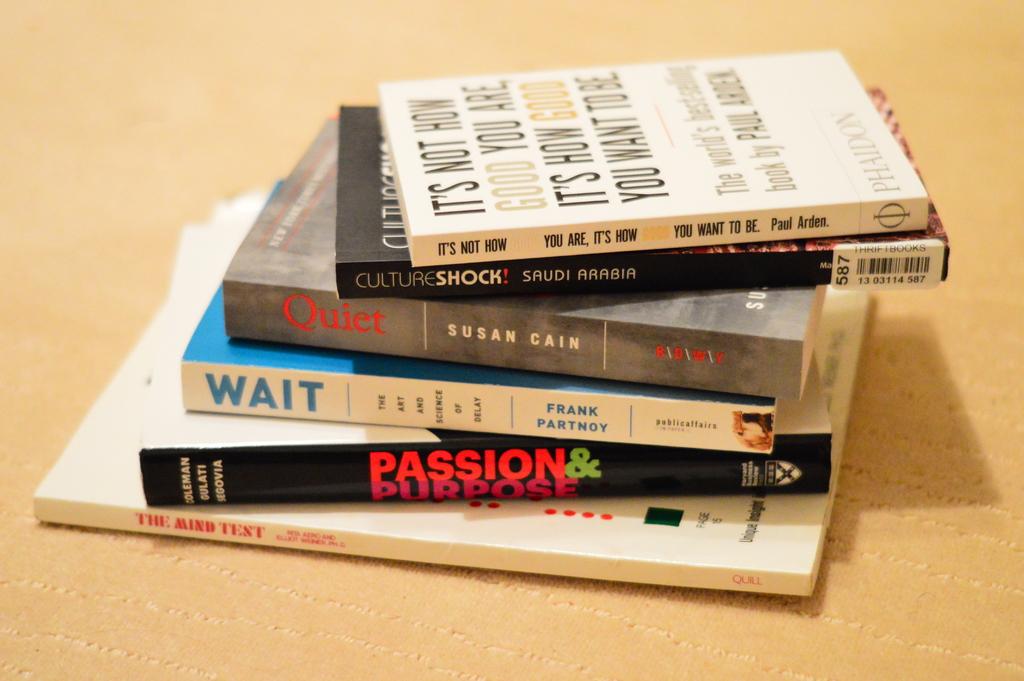Who wrote the top book?
Your answer should be compact. Paul arden. 